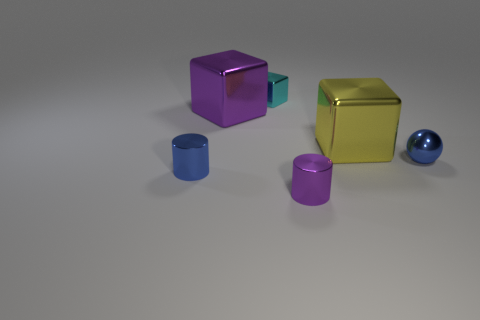Are there any yellow metal objects of the same shape as the cyan object?
Give a very brief answer. Yes. Is the big yellow object made of the same material as the cube to the left of the small cyan cube?
Ensure brevity in your answer.  Yes. The shiny thing that is behind the purple metal thing that is behind the cylinder that is to the left of the small cyan metallic block is what color?
Your answer should be compact. Cyan. There is a sphere that is the same size as the cyan block; what is its material?
Keep it short and to the point. Metal. How many small green objects are made of the same material as the yellow cube?
Offer a very short reply. 0. There is a yellow block that is to the right of the purple cylinder; is it the same size as the purple object that is behind the tiny blue shiny sphere?
Offer a terse response. Yes. There is a big metal cube left of the small purple metal object; what color is it?
Offer a terse response. Purple. There is a cylinder that is the same color as the metallic ball; what is it made of?
Ensure brevity in your answer.  Metal. What number of tiny metal objects are the same color as the small sphere?
Keep it short and to the point. 1. There is a purple cube; is it the same size as the metallic cylinder to the left of the cyan metal thing?
Your answer should be very brief. No. 